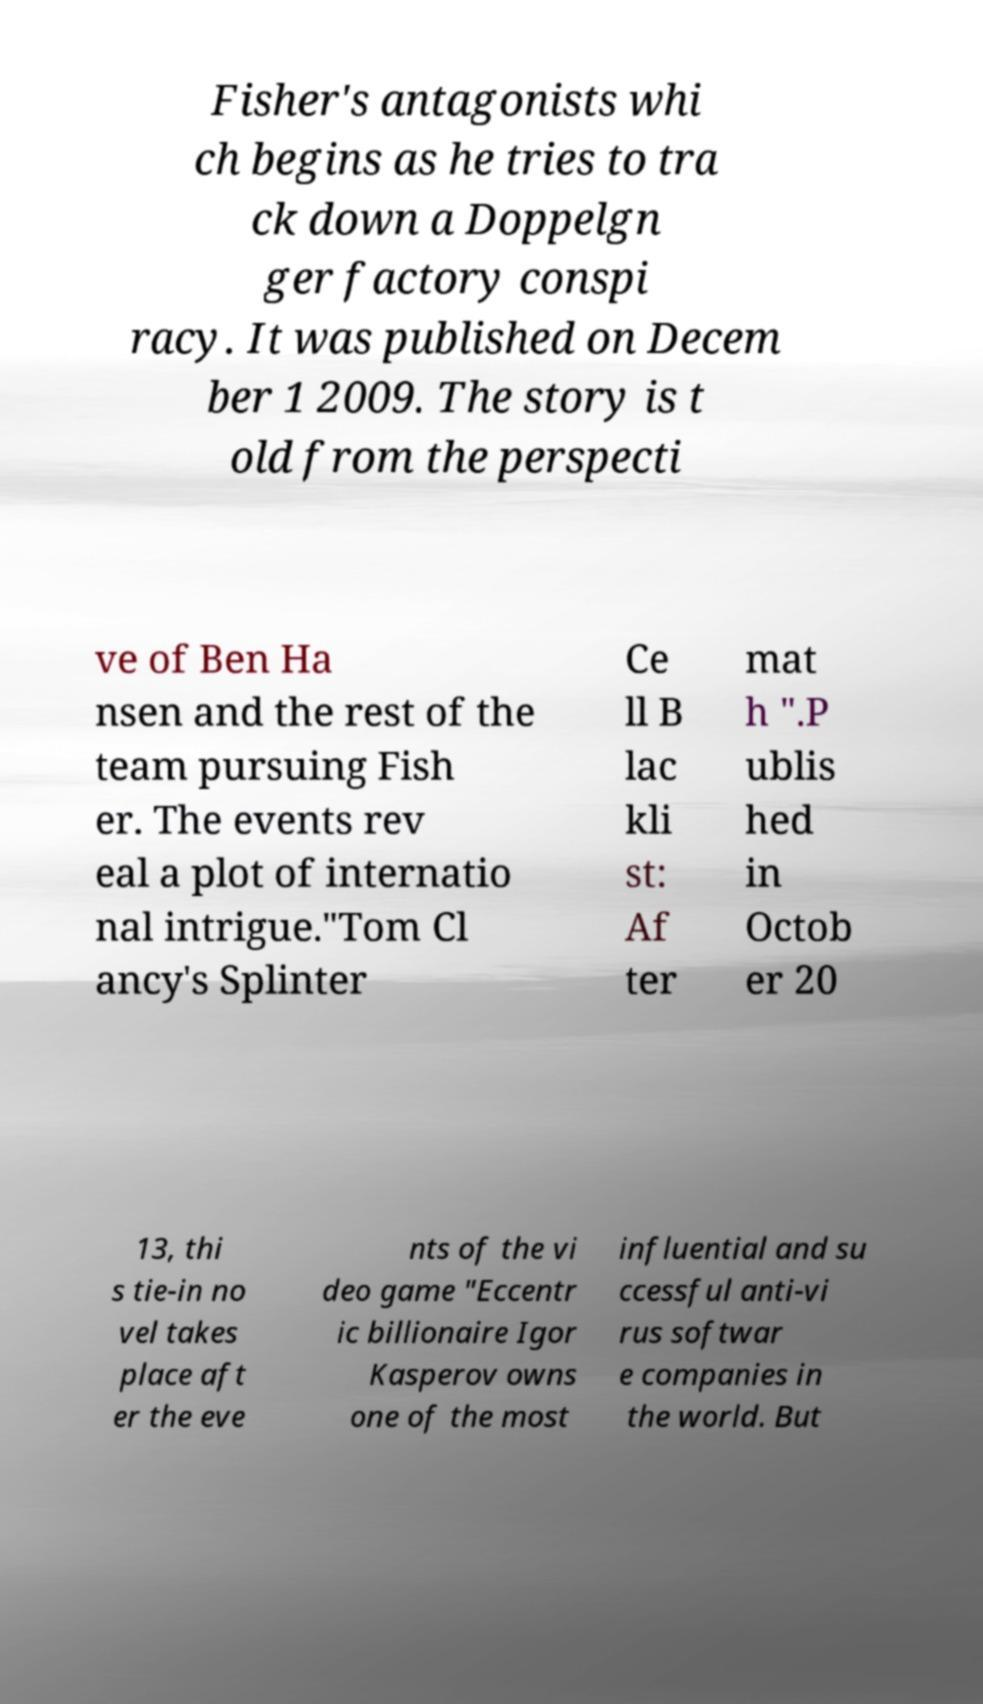Please read and relay the text visible in this image. What does it say? Fisher's antagonists whi ch begins as he tries to tra ck down a Doppelgn ger factory conspi racy. It was published on Decem ber 1 2009. The story is t old from the perspecti ve of Ben Ha nsen and the rest of the team pursuing Fish er. The events rev eal a plot of internatio nal intrigue."Tom Cl ancy's Splinter Ce ll B lac kli st: Af ter mat h ".P ublis hed in Octob er 20 13, thi s tie-in no vel takes place aft er the eve nts of the vi deo game "Eccentr ic billionaire Igor Kasperov owns one of the most influential and su ccessful anti-vi rus softwar e companies in the world. But 